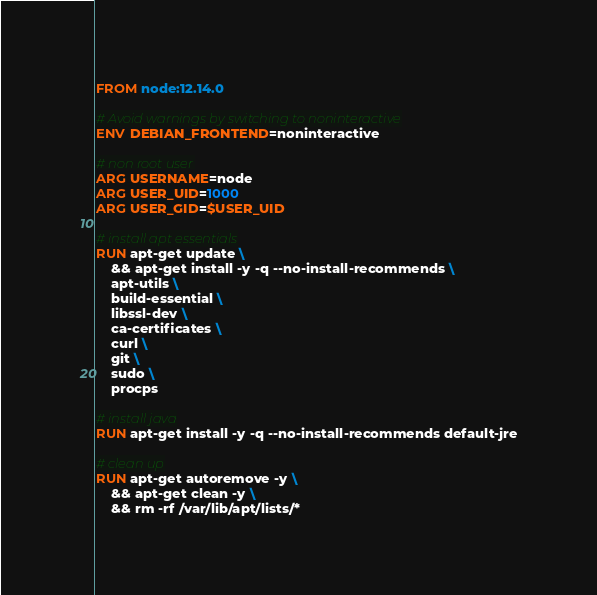Convert code to text. <code><loc_0><loc_0><loc_500><loc_500><_Dockerfile_>FROM node:12.14.0

# Avoid warnings by switching to noninteractive
ENV DEBIAN_FRONTEND=noninteractive

# non root user
ARG USERNAME=node
ARG USER_UID=1000
ARG USER_GID=$USER_UID

# install apt essentials
RUN apt-get update \
    && apt-get install -y -q --no-install-recommends \
    apt-utils \
    build-essential \
    libssl-dev \
    ca-certificates \
    curl \
    git \
    sudo \
    procps

# install java
RUN apt-get install -y -q --no-install-recommends default-jre

# clean up
RUN apt-get autoremove -y \
    && apt-get clean -y \
    && rm -rf /var/lib/apt/lists/*
</code> 